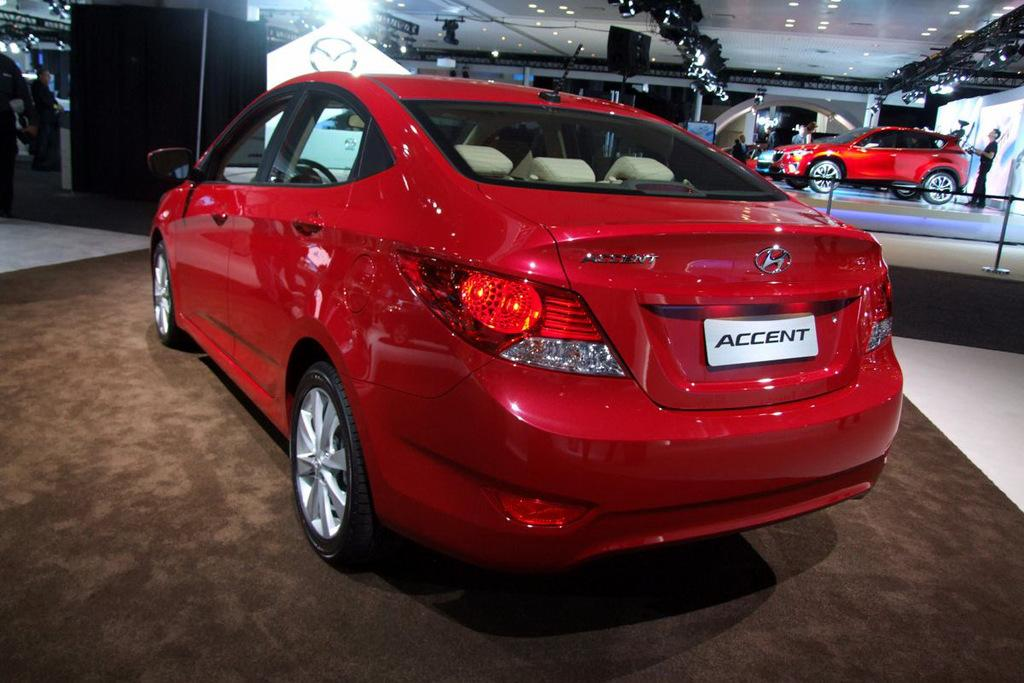What color is the car in the image? The car in the image is red. What is the surface beneath the car? The car is on a brown surface. What can be seen in the background of the image? In the background of the image, there are vehicles, people, a pillar, banners, lights, rods, and other objects. What type of lace is used to decorate the car in the image? There is no lace present on the car in the image. How much sugar is required to sweeten the car in the image? The car in the image is not a food item, so it does not require sugar. 